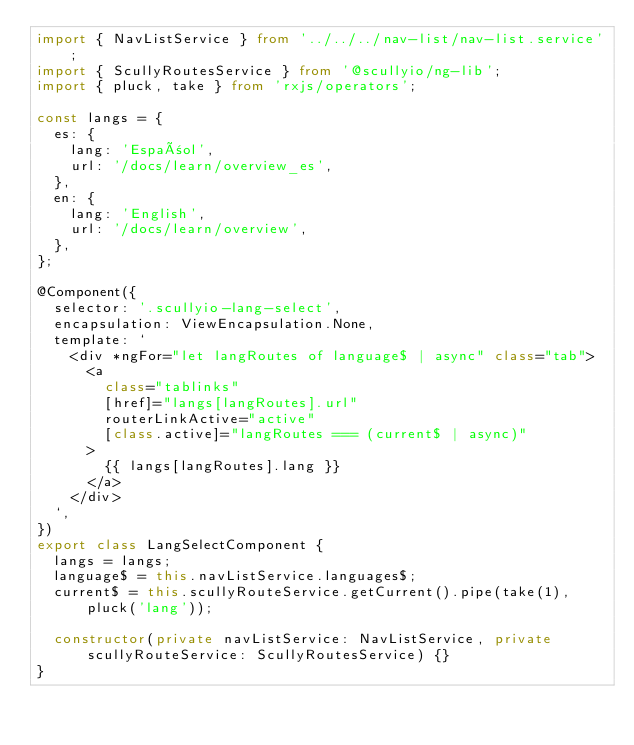<code> <loc_0><loc_0><loc_500><loc_500><_TypeScript_>import { NavListService } from '../../../nav-list/nav-list.service';
import { ScullyRoutesService } from '@scullyio/ng-lib';
import { pluck, take } from 'rxjs/operators';

const langs = {
  es: {
    lang: 'Español',
    url: '/docs/learn/overview_es',
  },
  en: {
    lang: 'English',
    url: '/docs/learn/overview',
  },
};

@Component({
  selector: '.scullyio-lang-select',
  encapsulation: ViewEncapsulation.None,
  template: `
    <div *ngFor="let langRoutes of language$ | async" class="tab">
      <a
        class="tablinks"
        [href]="langs[langRoutes].url"
        routerLinkActive="active"
        [class.active]="langRoutes === (current$ | async)"
      >
        {{ langs[langRoutes].lang }}
      </a>
    </div>
  `,
})
export class LangSelectComponent {
  langs = langs;
  language$ = this.navListService.languages$;
  current$ = this.scullyRouteService.getCurrent().pipe(take(1), pluck('lang'));

  constructor(private navListService: NavListService, private scullyRouteService: ScullyRoutesService) {}
}
</code> 